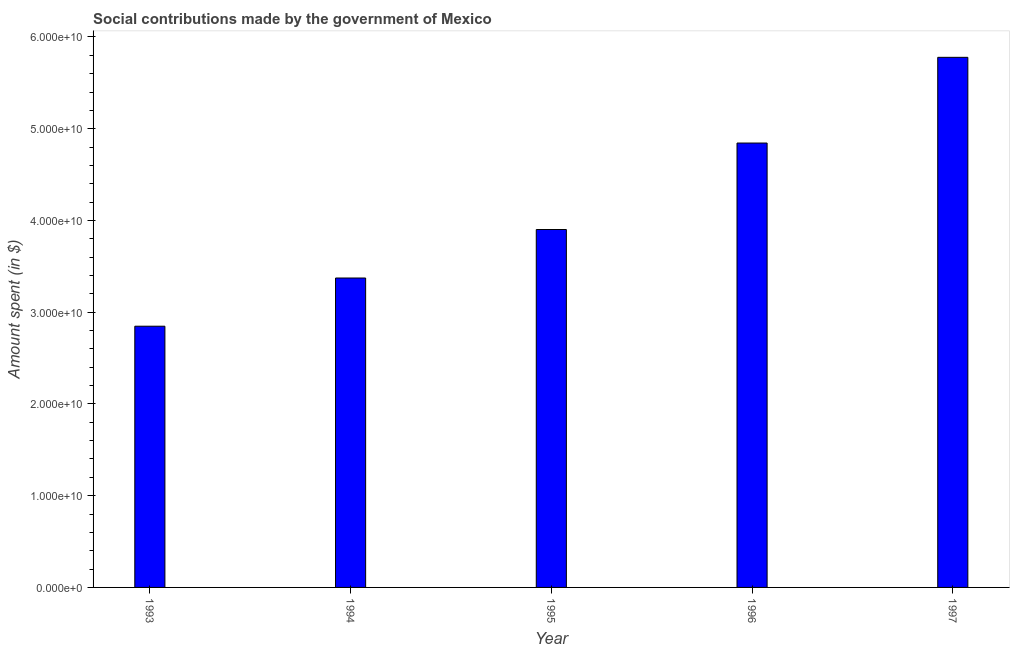Does the graph contain any zero values?
Make the answer very short. No. Does the graph contain grids?
Ensure brevity in your answer.  No. What is the title of the graph?
Your answer should be very brief. Social contributions made by the government of Mexico. What is the label or title of the Y-axis?
Ensure brevity in your answer.  Amount spent (in $). What is the amount spent in making social contributions in 1995?
Your response must be concise. 3.90e+1. Across all years, what is the maximum amount spent in making social contributions?
Offer a terse response. 5.78e+1. Across all years, what is the minimum amount spent in making social contributions?
Your answer should be very brief. 2.85e+1. In which year was the amount spent in making social contributions minimum?
Keep it short and to the point. 1993. What is the sum of the amount spent in making social contributions?
Give a very brief answer. 2.07e+11. What is the difference between the amount spent in making social contributions in 1994 and 1996?
Provide a succinct answer. -1.47e+1. What is the average amount spent in making social contributions per year?
Your answer should be very brief. 4.15e+1. What is the median amount spent in making social contributions?
Provide a short and direct response. 3.90e+1. In how many years, is the amount spent in making social contributions greater than 44000000000 $?
Your answer should be very brief. 2. Do a majority of the years between 1997 and 1996 (inclusive) have amount spent in making social contributions greater than 8000000000 $?
Your response must be concise. No. What is the ratio of the amount spent in making social contributions in 1993 to that in 1997?
Your response must be concise. 0.49. Is the amount spent in making social contributions in 1995 less than that in 1997?
Your answer should be compact. Yes. Is the difference between the amount spent in making social contributions in 1993 and 1996 greater than the difference between any two years?
Your answer should be very brief. No. What is the difference between the highest and the second highest amount spent in making social contributions?
Offer a terse response. 9.34e+09. What is the difference between the highest and the lowest amount spent in making social contributions?
Keep it short and to the point. 2.93e+1. In how many years, is the amount spent in making social contributions greater than the average amount spent in making social contributions taken over all years?
Provide a short and direct response. 2. Are all the bars in the graph horizontal?
Offer a terse response. No. How many years are there in the graph?
Provide a short and direct response. 5. What is the Amount spent (in $) in 1993?
Give a very brief answer. 2.85e+1. What is the Amount spent (in $) of 1994?
Make the answer very short. 3.37e+1. What is the Amount spent (in $) of 1995?
Your answer should be compact. 3.90e+1. What is the Amount spent (in $) in 1996?
Your answer should be compact. 4.84e+1. What is the Amount spent (in $) in 1997?
Your response must be concise. 5.78e+1. What is the difference between the Amount spent (in $) in 1993 and 1994?
Provide a short and direct response. -5.25e+09. What is the difference between the Amount spent (in $) in 1993 and 1995?
Provide a succinct answer. -1.05e+1. What is the difference between the Amount spent (in $) in 1993 and 1996?
Make the answer very short. -2.00e+1. What is the difference between the Amount spent (in $) in 1993 and 1997?
Ensure brevity in your answer.  -2.93e+1. What is the difference between the Amount spent (in $) in 1994 and 1995?
Your response must be concise. -5.29e+09. What is the difference between the Amount spent (in $) in 1994 and 1996?
Offer a very short reply. -1.47e+1. What is the difference between the Amount spent (in $) in 1994 and 1997?
Provide a succinct answer. -2.41e+1. What is the difference between the Amount spent (in $) in 1995 and 1996?
Offer a very short reply. -9.42e+09. What is the difference between the Amount spent (in $) in 1995 and 1997?
Ensure brevity in your answer.  -1.88e+1. What is the difference between the Amount spent (in $) in 1996 and 1997?
Provide a succinct answer. -9.34e+09. What is the ratio of the Amount spent (in $) in 1993 to that in 1994?
Offer a very short reply. 0.84. What is the ratio of the Amount spent (in $) in 1993 to that in 1995?
Your answer should be very brief. 0.73. What is the ratio of the Amount spent (in $) in 1993 to that in 1996?
Keep it short and to the point. 0.59. What is the ratio of the Amount spent (in $) in 1993 to that in 1997?
Provide a short and direct response. 0.49. What is the ratio of the Amount spent (in $) in 1994 to that in 1995?
Provide a short and direct response. 0.86. What is the ratio of the Amount spent (in $) in 1994 to that in 1996?
Your response must be concise. 0.7. What is the ratio of the Amount spent (in $) in 1994 to that in 1997?
Your response must be concise. 0.58. What is the ratio of the Amount spent (in $) in 1995 to that in 1996?
Give a very brief answer. 0.81. What is the ratio of the Amount spent (in $) in 1995 to that in 1997?
Provide a short and direct response. 0.68. What is the ratio of the Amount spent (in $) in 1996 to that in 1997?
Offer a very short reply. 0.84. 